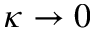Convert formula to latex. <formula><loc_0><loc_0><loc_500><loc_500>\kappa \to 0</formula> 